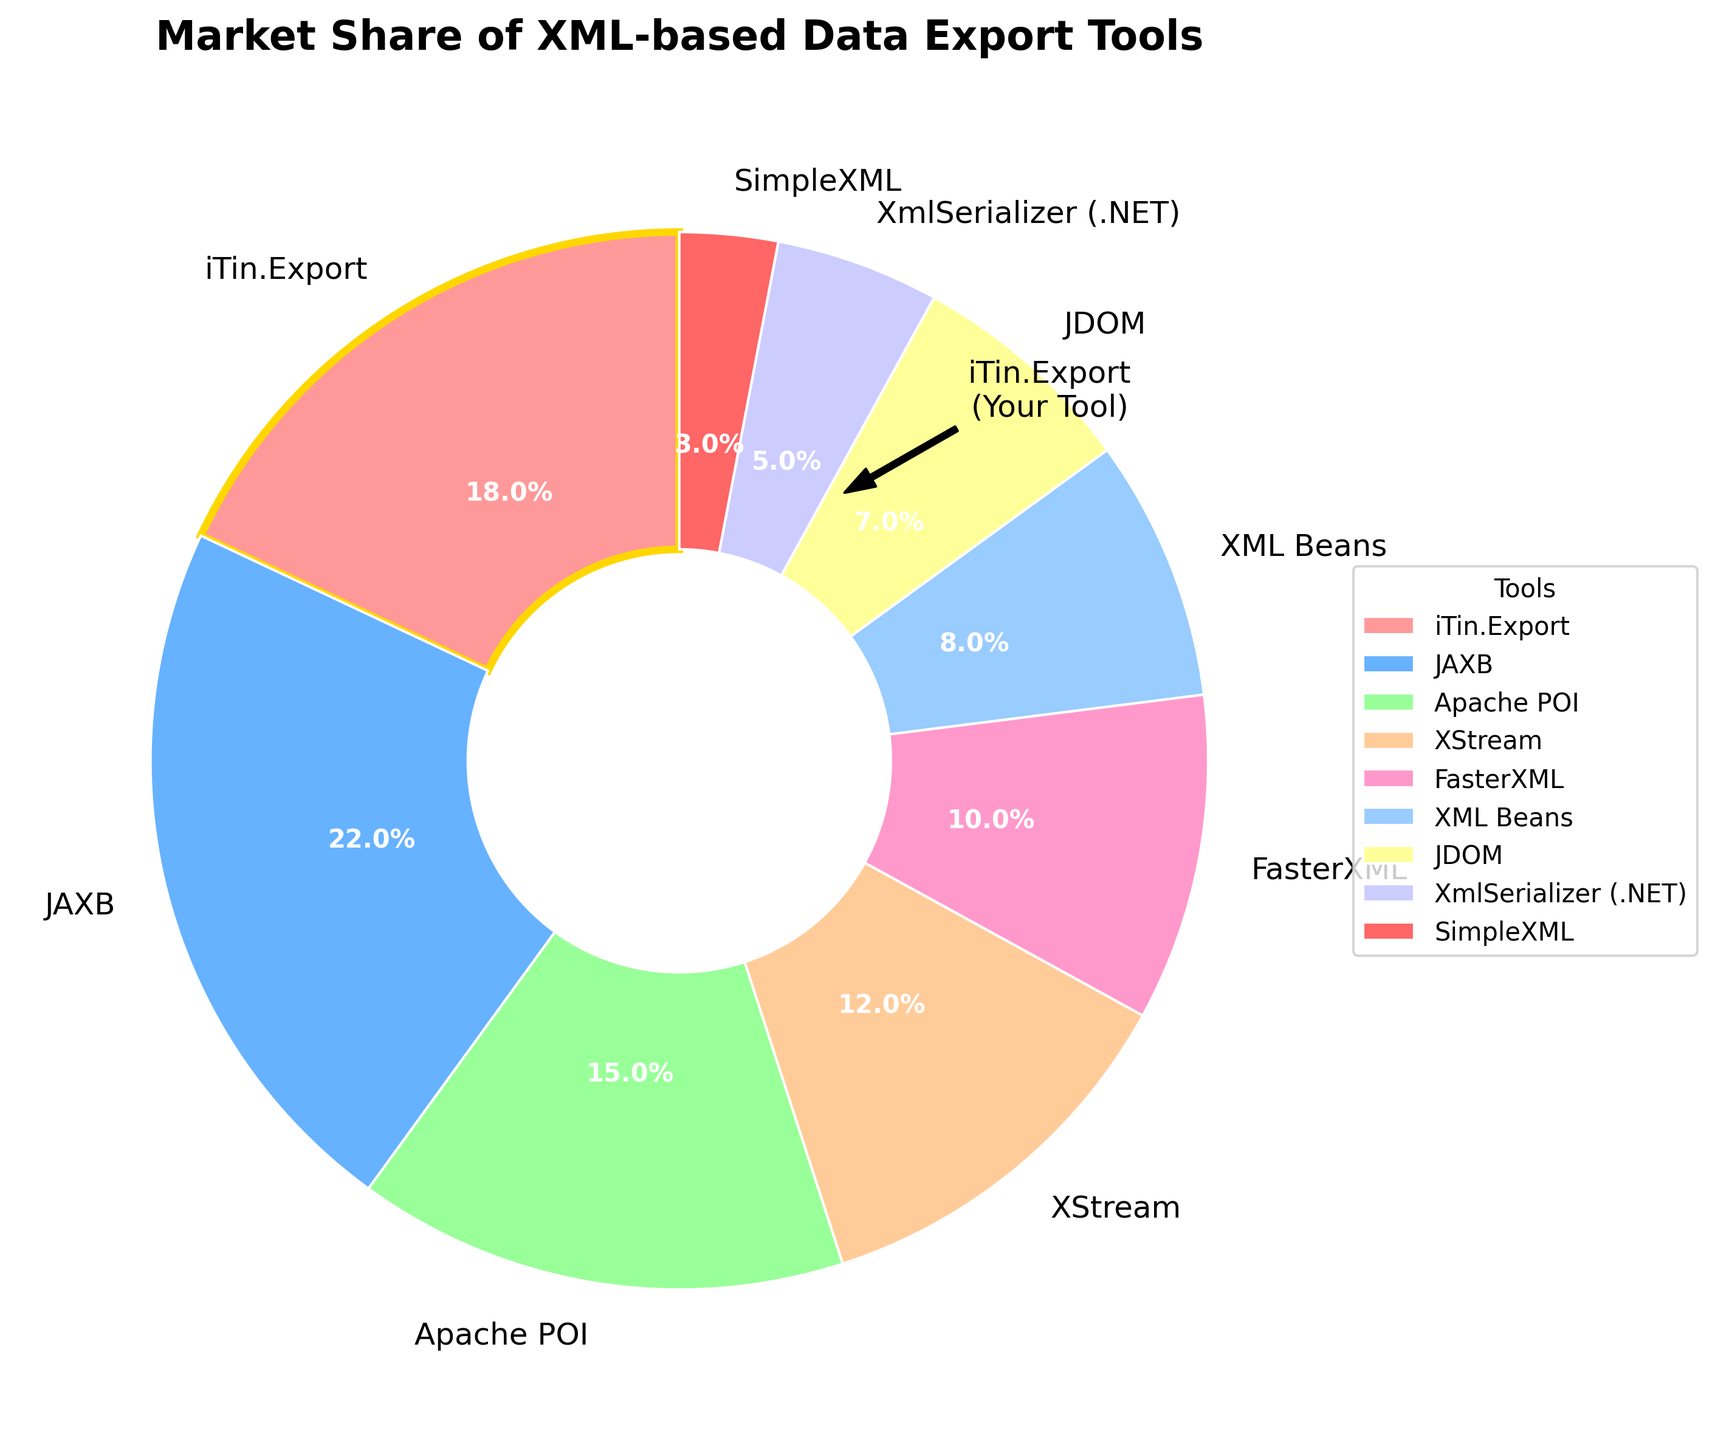What's the market share of the tool iTin.Export? The chart shows the market shares of various XML-based data export tools, and by identifying "iTin.Export" in the legend, we can see that its market share is indicated as 18%.
Answer: 18% Which tool has the largest market share? The chart segments show different market shares, and by comparing the sizes of segments, we can see that "JAXB" has the largest segment, indicating it has the largest market share at 22%.
Answer: JAXB Which tool has a smaller market share, XML Beans or JDOM? By looking at the sizes of the pie segments, we compare the market share percentages of "XML Beans" (8%) and "JDOM" (7%). XML Beans has a slightly larger share.
Answer: JDOM What is the combined market share of the tools Apache POI and FasterXML? From the pie chart, find "Apache POI" and "FasterXML" and note their market shares, which are 15% and 10% respectively. Adding these together gives a combined market share of 25%.
Answer: 25% Which two tools have a combined market share equal to the market share of JAXB? "JAXB" has a market share of 22%. Look for two tools whose combined market share equals 22%. "Apache POI" (15%) and "SimpleXML" (3%) together account for 18%, and "XStream" (12%) and "XML Beans" (8%) together account for 20%. Finally, "iTin.Export" (18%) and "SimpleXML" (3%) together account for 21%, as well as "Apache POI" (15%) and "XmlSerializer (.NET)" (5%) totaling 20%. Therefore, no pair exactly matches 22%.
Answer: None What tool has the smallest market share, and what is its percentage? The smallest segment in the pie chart represents SimpleXML with the smallest market share at 3%.
Answer: SimpleXML, 3% How much larger is the market share of JAXB than iTin.Export? The market share of JAXB is 22%, and iTin.Export is 18%. The difference is calculated as 22% - 18% = 4%.
Answer: 4% Arrange the tools iTin.Export, JAXB, and XStream in descending order according to their market shares. Identify the segments for iTin.Export (18%), JAXB (22%), and XStream (12%) and then arrange these percentages in descending order: 22%, 18%, 12%.
Answer: JAXB, iTin.Export, XStream Which tool's segment is highlighted with a special edge color? Upon visually scanning the chart, it's evident that the segment for "iTin.Export" is outlined in gold, indicating a special highlight.
Answer: iTin.Export What percentage of the market is captured by tools other than JAXB and iTin.Export combined? First, sum the market shares of all tools: 18 (iTin.Export) + 22 (JAXB) + 15 (Apache POI) + 12 (XStream) + 10 (FasterXML) + 8 (XML Beans) + 7 (JDOM) + 5 (XmlSerializer (.NET)) + 3 (SimpleXML) = 100%. Subtract the combined share of JAXB and iTin.Export (total 40%): 100% – 40% = 60%.
Answer: 60% 